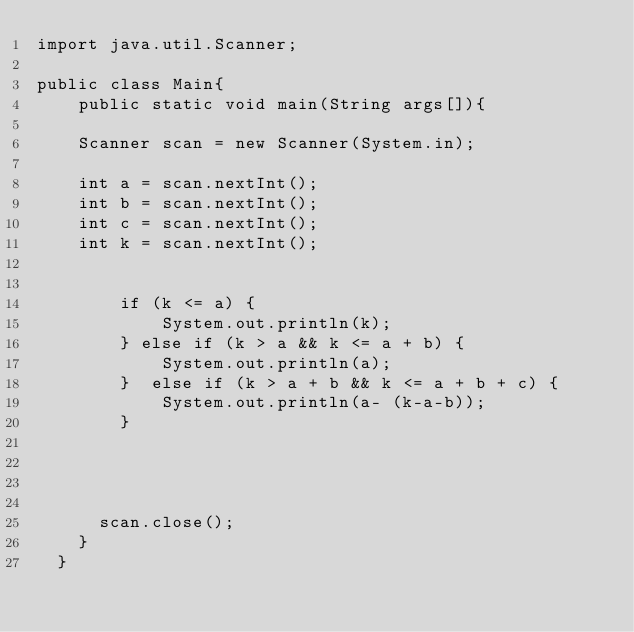<code> <loc_0><loc_0><loc_500><loc_500><_Java_>import java.util.Scanner;

public class Main{
    public static void main(String args[]){

    Scanner scan = new Scanner(System.in);

    int a = scan.nextInt();
    int b = scan.nextInt();
    int c = scan.nextInt();
    int k = scan.nextInt();
    
    
        if (k <= a) {
            System.out.println(k);
        } else if (k > a && k <= a + b) {
            System.out.println(a);
        }  else if (k > a + b && k <= a + b + c) {
            System.out.println(a- (k-a-b));
        } 
    
      


      scan.close();
    }
  }</code> 